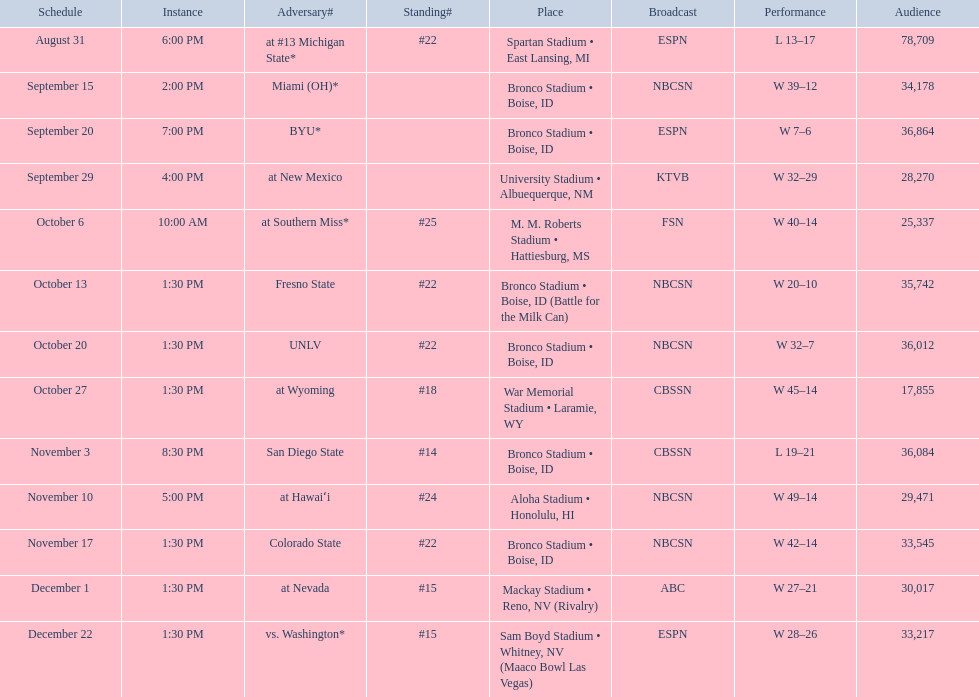What rank was boise state after november 10th? #22. 